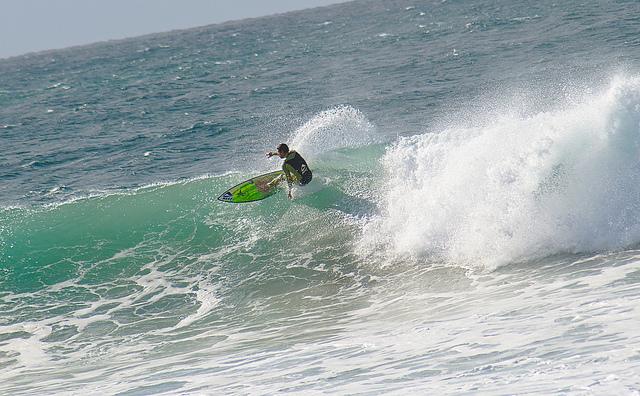What is the man doing?
Short answer required. Surfing. How many people are surfing?
Short answer required. 1. Is there a storm coming?
Give a very brief answer. No. Island nearby?
Concise answer only. No. Is this a big wave?
Be succinct. Yes. What color is the surfer's board?
Answer briefly. Green. What color is the surfboard?
Keep it brief. Green. How many surfers are in the picture?
Short answer required. 1. 